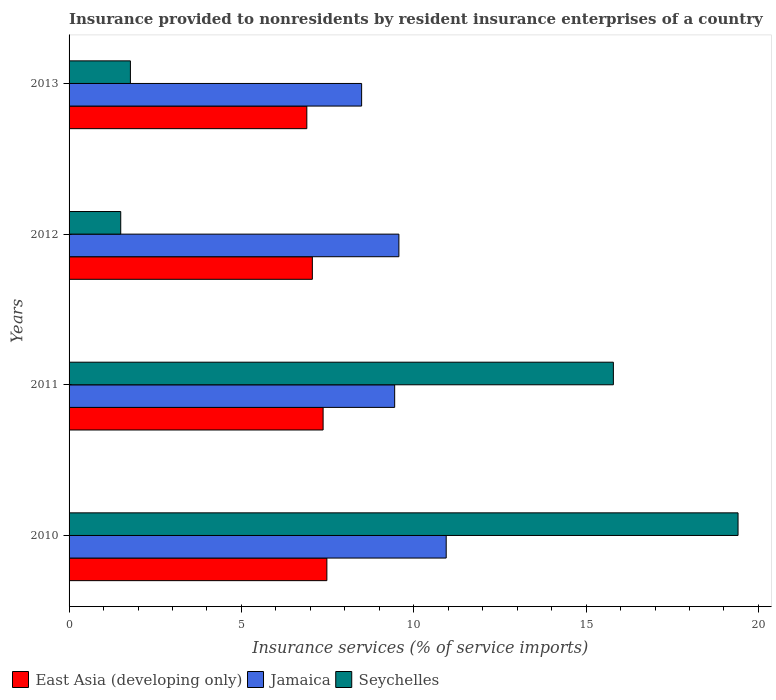How many different coloured bars are there?
Provide a succinct answer. 3. How many bars are there on the 2nd tick from the top?
Provide a succinct answer. 3. What is the label of the 3rd group of bars from the top?
Offer a terse response. 2011. In how many cases, is the number of bars for a given year not equal to the number of legend labels?
Make the answer very short. 0. What is the insurance provided to nonresidents in Jamaica in 2010?
Provide a succinct answer. 10.94. Across all years, what is the maximum insurance provided to nonresidents in Seychelles?
Your answer should be compact. 19.41. Across all years, what is the minimum insurance provided to nonresidents in East Asia (developing only)?
Your answer should be very brief. 6.9. In which year was the insurance provided to nonresidents in East Asia (developing only) maximum?
Your response must be concise. 2010. What is the total insurance provided to nonresidents in Jamaica in the graph?
Provide a succinct answer. 38.45. What is the difference between the insurance provided to nonresidents in East Asia (developing only) in 2012 and that in 2013?
Your answer should be very brief. 0.16. What is the difference between the insurance provided to nonresidents in East Asia (developing only) in 2010 and the insurance provided to nonresidents in Seychelles in 2011?
Ensure brevity in your answer.  -8.31. What is the average insurance provided to nonresidents in Jamaica per year?
Offer a terse response. 9.61. In the year 2012, what is the difference between the insurance provided to nonresidents in Jamaica and insurance provided to nonresidents in East Asia (developing only)?
Keep it short and to the point. 2.51. In how many years, is the insurance provided to nonresidents in East Asia (developing only) greater than 14 %?
Provide a succinct answer. 0. What is the ratio of the insurance provided to nonresidents in Jamaica in 2010 to that in 2012?
Ensure brevity in your answer.  1.14. What is the difference between the highest and the second highest insurance provided to nonresidents in Seychelles?
Your response must be concise. 3.62. What is the difference between the highest and the lowest insurance provided to nonresidents in Seychelles?
Your response must be concise. 17.91. What does the 1st bar from the top in 2011 represents?
Your answer should be compact. Seychelles. What does the 1st bar from the bottom in 2011 represents?
Your answer should be very brief. East Asia (developing only). What is the difference between two consecutive major ticks on the X-axis?
Make the answer very short. 5. Does the graph contain any zero values?
Ensure brevity in your answer.  No. Where does the legend appear in the graph?
Your answer should be compact. Bottom left. How many legend labels are there?
Ensure brevity in your answer.  3. How are the legend labels stacked?
Ensure brevity in your answer.  Horizontal. What is the title of the graph?
Your answer should be very brief. Insurance provided to nonresidents by resident insurance enterprises of a country. Does "Chad" appear as one of the legend labels in the graph?
Give a very brief answer. No. What is the label or title of the X-axis?
Provide a succinct answer. Insurance services (% of service imports). What is the label or title of the Y-axis?
Offer a very short reply. Years. What is the Insurance services (% of service imports) in East Asia (developing only) in 2010?
Provide a short and direct response. 7.48. What is the Insurance services (% of service imports) of Jamaica in 2010?
Keep it short and to the point. 10.94. What is the Insurance services (% of service imports) in Seychelles in 2010?
Keep it short and to the point. 19.41. What is the Insurance services (% of service imports) of East Asia (developing only) in 2011?
Your response must be concise. 7.37. What is the Insurance services (% of service imports) of Jamaica in 2011?
Offer a terse response. 9.45. What is the Insurance services (% of service imports) of Seychelles in 2011?
Give a very brief answer. 15.79. What is the Insurance services (% of service imports) in East Asia (developing only) in 2012?
Provide a short and direct response. 7.06. What is the Insurance services (% of service imports) in Jamaica in 2012?
Provide a short and direct response. 9.57. What is the Insurance services (% of service imports) in Seychelles in 2012?
Offer a terse response. 1.5. What is the Insurance services (% of service imports) in East Asia (developing only) in 2013?
Your answer should be compact. 6.9. What is the Insurance services (% of service imports) in Jamaica in 2013?
Your answer should be very brief. 8.49. What is the Insurance services (% of service imports) of Seychelles in 2013?
Provide a short and direct response. 1.78. Across all years, what is the maximum Insurance services (% of service imports) of East Asia (developing only)?
Keep it short and to the point. 7.48. Across all years, what is the maximum Insurance services (% of service imports) in Jamaica?
Offer a terse response. 10.94. Across all years, what is the maximum Insurance services (% of service imports) of Seychelles?
Keep it short and to the point. 19.41. Across all years, what is the minimum Insurance services (% of service imports) in East Asia (developing only)?
Give a very brief answer. 6.9. Across all years, what is the minimum Insurance services (% of service imports) in Jamaica?
Provide a succinct answer. 8.49. Across all years, what is the minimum Insurance services (% of service imports) in Seychelles?
Provide a short and direct response. 1.5. What is the total Insurance services (% of service imports) of East Asia (developing only) in the graph?
Offer a very short reply. 28.81. What is the total Insurance services (% of service imports) in Jamaica in the graph?
Provide a short and direct response. 38.45. What is the total Insurance services (% of service imports) in Seychelles in the graph?
Your response must be concise. 38.48. What is the difference between the Insurance services (% of service imports) in East Asia (developing only) in 2010 and that in 2011?
Your answer should be very brief. 0.11. What is the difference between the Insurance services (% of service imports) of Jamaica in 2010 and that in 2011?
Provide a short and direct response. 1.5. What is the difference between the Insurance services (% of service imports) in Seychelles in 2010 and that in 2011?
Your answer should be very brief. 3.62. What is the difference between the Insurance services (% of service imports) of East Asia (developing only) in 2010 and that in 2012?
Give a very brief answer. 0.42. What is the difference between the Insurance services (% of service imports) of Jamaica in 2010 and that in 2012?
Offer a terse response. 1.37. What is the difference between the Insurance services (% of service imports) of Seychelles in 2010 and that in 2012?
Your answer should be very brief. 17.91. What is the difference between the Insurance services (% of service imports) of East Asia (developing only) in 2010 and that in 2013?
Give a very brief answer. 0.58. What is the difference between the Insurance services (% of service imports) of Jamaica in 2010 and that in 2013?
Provide a short and direct response. 2.45. What is the difference between the Insurance services (% of service imports) in Seychelles in 2010 and that in 2013?
Your answer should be very brief. 17.63. What is the difference between the Insurance services (% of service imports) in East Asia (developing only) in 2011 and that in 2012?
Ensure brevity in your answer.  0.31. What is the difference between the Insurance services (% of service imports) of Jamaica in 2011 and that in 2012?
Your response must be concise. -0.12. What is the difference between the Insurance services (% of service imports) of Seychelles in 2011 and that in 2012?
Offer a terse response. 14.29. What is the difference between the Insurance services (% of service imports) in East Asia (developing only) in 2011 and that in 2013?
Offer a very short reply. 0.47. What is the difference between the Insurance services (% of service imports) in Jamaica in 2011 and that in 2013?
Your answer should be compact. 0.96. What is the difference between the Insurance services (% of service imports) of Seychelles in 2011 and that in 2013?
Make the answer very short. 14.01. What is the difference between the Insurance services (% of service imports) in East Asia (developing only) in 2012 and that in 2013?
Ensure brevity in your answer.  0.16. What is the difference between the Insurance services (% of service imports) of Jamaica in 2012 and that in 2013?
Make the answer very short. 1.08. What is the difference between the Insurance services (% of service imports) of Seychelles in 2012 and that in 2013?
Your answer should be compact. -0.28. What is the difference between the Insurance services (% of service imports) in East Asia (developing only) in 2010 and the Insurance services (% of service imports) in Jamaica in 2011?
Your answer should be very brief. -1.97. What is the difference between the Insurance services (% of service imports) in East Asia (developing only) in 2010 and the Insurance services (% of service imports) in Seychelles in 2011?
Offer a very short reply. -8.31. What is the difference between the Insurance services (% of service imports) in Jamaica in 2010 and the Insurance services (% of service imports) in Seychelles in 2011?
Your answer should be very brief. -4.85. What is the difference between the Insurance services (% of service imports) of East Asia (developing only) in 2010 and the Insurance services (% of service imports) of Jamaica in 2012?
Your response must be concise. -2.09. What is the difference between the Insurance services (% of service imports) of East Asia (developing only) in 2010 and the Insurance services (% of service imports) of Seychelles in 2012?
Ensure brevity in your answer.  5.98. What is the difference between the Insurance services (% of service imports) of Jamaica in 2010 and the Insurance services (% of service imports) of Seychelles in 2012?
Give a very brief answer. 9.44. What is the difference between the Insurance services (% of service imports) in East Asia (developing only) in 2010 and the Insurance services (% of service imports) in Jamaica in 2013?
Make the answer very short. -1.01. What is the difference between the Insurance services (% of service imports) in East Asia (developing only) in 2010 and the Insurance services (% of service imports) in Seychelles in 2013?
Offer a very short reply. 5.7. What is the difference between the Insurance services (% of service imports) of Jamaica in 2010 and the Insurance services (% of service imports) of Seychelles in 2013?
Ensure brevity in your answer.  9.16. What is the difference between the Insurance services (% of service imports) in East Asia (developing only) in 2011 and the Insurance services (% of service imports) in Jamaica in 2012?
Make the answer very short. -2.2. What is the difference between the Insurance services (% of service imports) of East Asia (developing only) in 2011 and the Insurance services (% of service imports) of Seychelles in 2012?
Keep it short and to the point. 5.87. What is the difference between the Insurance services (% of service imports) of Jamaica in 2011 and the Insurance services (% of service imports) of Seychelles in 2012?
Provide a short and direct response. 7.95. What is the difference between the Insurance services (% of service imports) in East Asia (developing only) in 2011 and the Insurance services (% of service imports) in Jamaica in 2013?
Make the answer very short. -1.12. What is the difference between the Insurance services (% of service imports) of East Asia (developing only) in 2011 and the Insurance services (% of service imports) of Seychelles in 2013?
Your answer should be very brief. 5.59. What is the difference between the Insurance services (% of service imports) of Jamaica in 2011 and the Insurance services (% of service imports) of Seychelles in 2013?
Your answer should be compact. 7.67. What is the difference between the Insurance services (% of service imports) in East Asia (developing only) in 2012 and the Insurance services (% of service imports) in Jamaica in 2013?
Provide a succinct answer. -1.43. What is the difference between the Insurance services (% of service imports) of East Asia (developing only) in 2012 and the Insurance services (% of service imports) of Seychelles in 2013?
Keep it short and to the point. 5.28. What is the difference between the Insurance services (% of service imports) of Jamaica in 2012 and the Insurance services (% of service imports) of Seychelles in 2013?
Make the answer very short. 7.79. What is the average Insurance services (% of service imports) in East Asia (developing only) per year?
Give a very brief answer. 7.2. What is the average Insurance services (% of service imports) of Jamaica per year?
Provide a succinct answer. 9.61. What is the average Insurance services (% of service imports) of Seychelles per year?
Provide a short and direct response. 9.62. In the year 2010, what is the difference between the Insurance services (% of service imports) in East Asia (developing only) and Insurance services (% of service imports) in Jamaica?
Ensure brevity in your answer.  -3.46. In the year 2010, what is the difference between the Insurance services (% of service imports) of East Asia (developing only) and Insurance services (% of service imports) of Seychelles?
Ensure brevity in your answer.  -11.93. In the year 2010, what is the difference between the Insurance services (% of service imports) in Jamaica and Insurance services (% of service imports) in Seychelles?
Your answer should be very brief. -8.47. In the year 2011, what is the difference between the Insurance services (% of service imports) of East Asia (developing only) and Insurance services (% of service imports) of Jamaica?
Your answer should be compact. -2.08. In the year 2011, what is the difference between the Insurance services (% of service imports) in East Asia (developing only) and Insurance services (% of service imports) in Seychelles?
Your response must be concise. -8.42. In the year 2011, what is the difference between the Insurance services (% of service imports) of Jamaica and Insurance services (% of service imports) of Seychelles?
Your answer should be compact. -6.35. In the year 2012, what is the difference between the Insurance services (% of service imports) of East Asia (developing only) and Insurance services (% of service imports) of Jamaica?
Provide a succinct answer. -2.51. In the year 2012, what is the difference between the Insurance services (% of service imports) of East Asia (developing only) and Insurance services (% of service imports) of Seychelles?
Keep it short and to the point. 5.56. In the year 2012, what is the difference between the Insurance services (% of service imports) in Jamaica and Insurance services (% of service imports) in Seychelles?
Provide a short and direct response. 8.07. In the year 2013, what is the difference between the Insurance services (% of service imports) of East Asia (developing only) and Insurance services (% of service imports) of Jamaica?
Your response must be concise. -1.59. In the year 2013, what is the difference between the Insurance services (% of service imports) of East Asia (developing only) and Insurance services (% of service imports) of Seychelles?
Your response must be concise. 5.12. In the year 2013, what is the difference between the Insurance services (% of service imports) of Jamaica and Insurance services (% of service imports) of Seychelles?
Keep it short and to the point. 6.71. What is the ratio of the Insurance services (% of service imports) in East Asia (developing only) in 2010 to that in 2011?
Offer a very short reply. 1.01. What is the ratio of the Insurance services (% of service imports) of Jamaica in 2010 to that in 2011?
Provide a short and direct response. 1.16. What is the ratio of the Insurance services (% of service imports) of Seychelles in 2010 to that in 2011?
Your answer should be very brief. 1.23. What is the ratio of the Insurance services (% of service imports) of East Asia (developing only) in 2010 to that in 2012?
Your response must be concise. 1.06. What is the ratio of the Insurance services (% of service imports) in Jamaica in 2010 to that in 2012?
Keep it short and to the point. 1.14. What is the ratio of the Insurance services (% of service imports) of Seychelles in 2010 to that in 2012?
Ensure brevity in your answer.  12.95. What is the ratio of the Insurance services (% of service imports) in East Asia (developing only) in 2010 to that in 2013?
Provide a short and direct response. 1.08. What is the ratio of the Insurance services (% of service imports) of Jamaica in 2010 to that in 2013?
Provide a short and direct response. 1.29. What is the ratio of the Insurance services (% of service imports) of Seychelles in 2010 to that in 2013?
Your answer should be very brief. 10.91. What is the ratio of the Insurance services (% of service imports) of East Asia (developing only) in 2011 to that in 2012?
Your response must be concise. 1.04. What is the ratio of the Insurance services (% of service imports) in Jamaica in 2011 to that in 2012?
Provide a short and direct response. 0.99. What is the ratio of the Insurance services (% of service imports) in Seychelles in 2011 to that in 2012?
Your answer should be compact. 10.54. What is the ratio of the Insurance services (% of service imports) of East Asia (developing only) in 2011 to that in 2013?
Provide a succinct answer. 1.07. What is the ratio of the Insurance services (% of service imports) in Jamaica in 2011 to that in 2013?
Ensure brevity in your answer.  1.11. What is the ratio of the Insurance services (% of service imports) of Seychelles in 2011 to that in 2013?
Ensure brevity in your answer.  8.87. What is the ratio of the Insurance services (% of service imports) in East Asia (developing only) in 2012 to that in 2013?
Provide a succinct answer. 1.02. What is the ratio of the Insurance services (% of service imports) of Jamaica in 2012 to that in 2013?
Keep it short and to the point. 1.13. What is the ratio of the Insurance services (% of service imports) of Seychelles in 2012 to that in 2013?
Your response must be concise. 0.84. What is the difference between the highest and the second highest Insurance services (% of service imports) in East Asia (developing only)?
Keep it short and to the point. 0.11. What is the difference between the highest and the second highest Insurance services (% of service imports) in Jamaica?
Your answer should be compact. 1.37. What is the difference between the highest and the second highest Insurance services (% of service imports) of Seychelles?
Make the answer very short. 3.62. What is the difference between the highest and the lowest Insurance services (% of service imports) in East Asia (developing only)?
Provide a succinct answer. 0.58. What is the difference between the highest and the lowest Insurance services (% of service imports) in Jamaica?
Provide a short and direct response. 2.45. What is the difference between the highest and the lowest Insurance services (% of service imports) in Seychelles?
Offer a terse response. 17.91. 